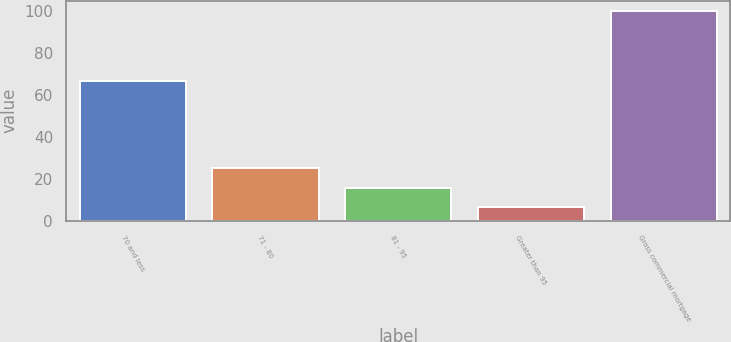Convert chart to OTSL. <chart><loc_0><loc_0><loc_500><loc_500><bar_chart><fcel>70 and less<fcel>71 - 80<fcel>81 - 95<fcel>Greater than 95<fcel>Gross commercial mortgage<nl><fcel>66.6<fcel>25.12<fcel>15.76<fcel>6.4<fcel>100<nl></chart> 